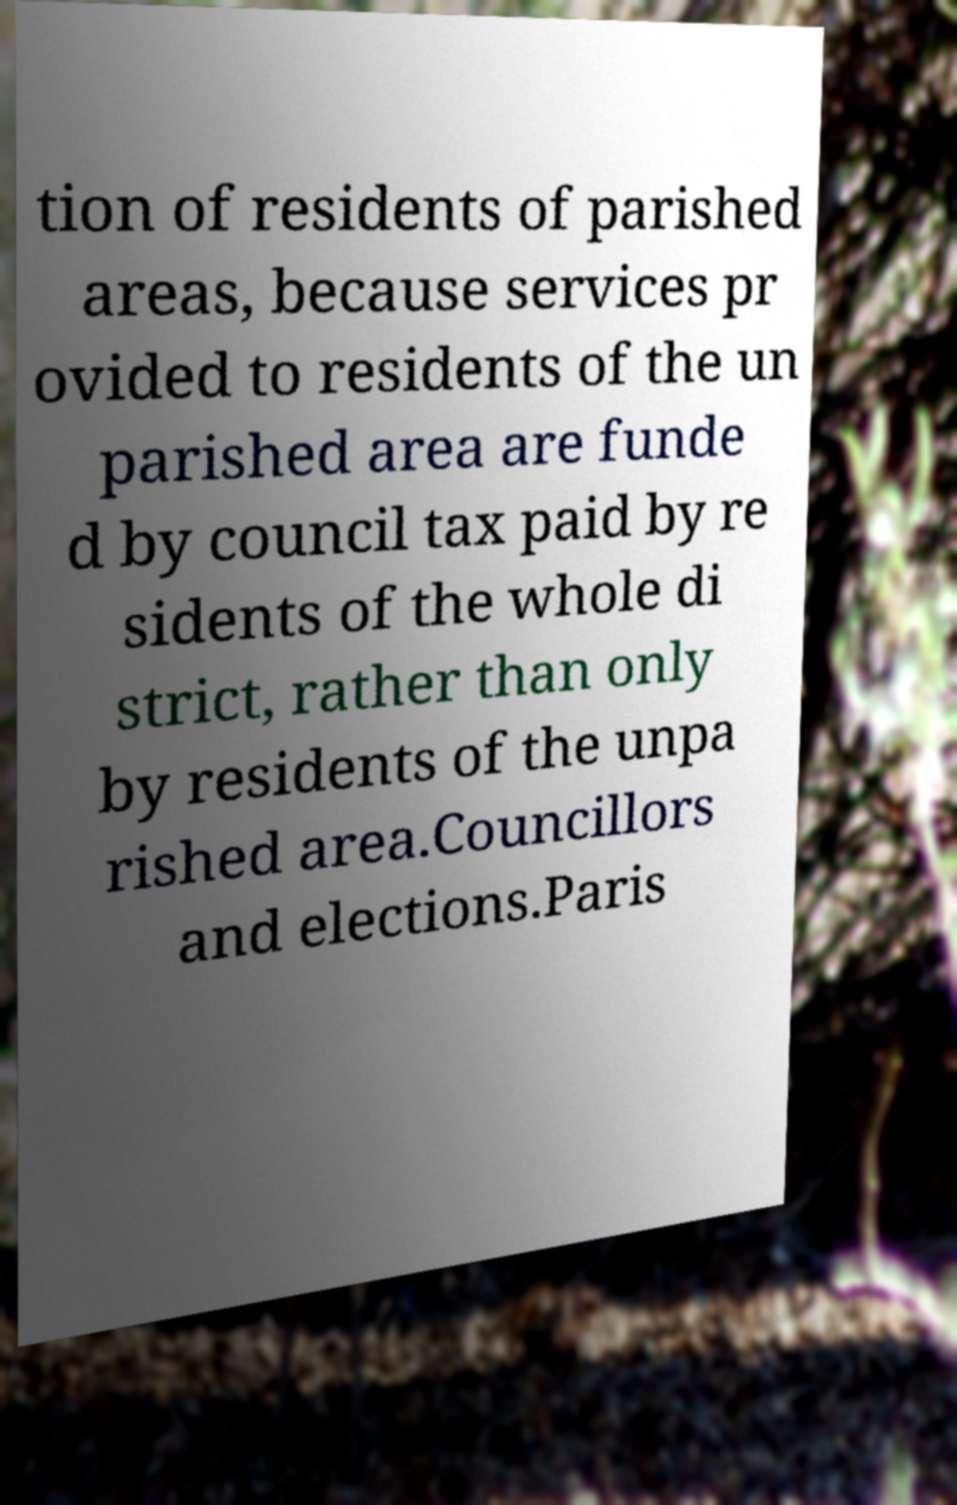I need the written content from this picture converted into text. Can you do that? tion of residents of parished areas, because services pr ovided to residents of the un parished area are funde d by council tax paid by re sidents of the whole di strict, rather than only by residents of the unpa rished area.Councillors and elections.Paris 